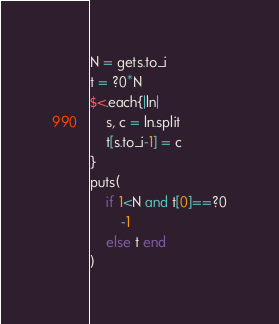Convert code to text. <code><loc_0><loc_0><loc_500><loc_500><_Ruby_>N = gets.to_i
t = ?0*N
$<.each{|ln|
	s, c = ln.split
	t[s.to_i-1] = c
}
puts(
	if 1<N and t[0]==?0
		-1
	else t end
)
</code> 